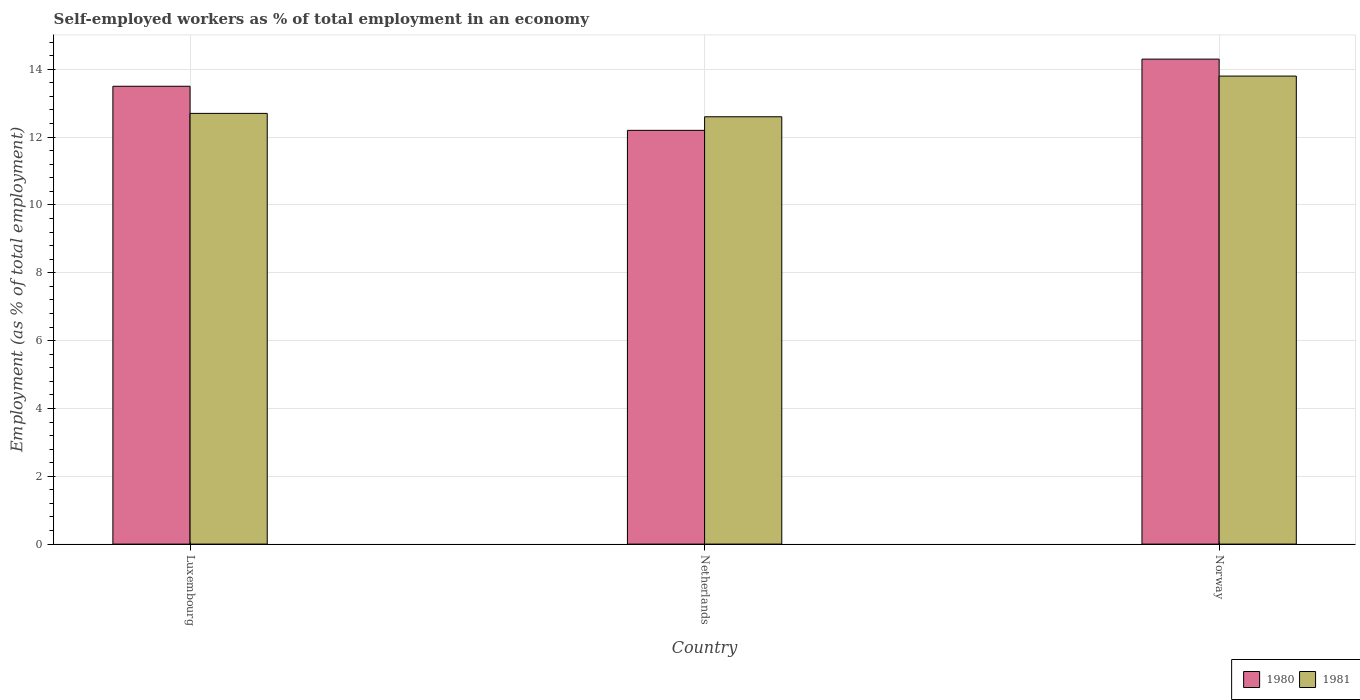How many different coloured bars are there?
Ensure brevity in your answer.  2. Are the number of bars per tick equal to the number of legend labels?
Provide a short and direct response. Yes. How many bars are there on the 1st tick from the left?
Provide a short and direct response. 2. What is the label of the 2nd group of bars from the left?
Your answer should be compact. Netherlands. In how many cases, is the number of bars for a given country not equal to the number of legend labels?
Offer a very short reply. 0. What is the percentage of self-employed workers in 1980 in Norway?
Ensure brevity in your answer.  14.3. Across all countries, what is the maximum percentage of self-employed workers in 1981?
Ensure brevity in your answer.  13.8. Across all countries, what is the minimum percentage of self-employed workers in 1981?
Your answer should be compact. 12.6. What is the total percentage of self-employed workers in 1981 in the graph?
Make the answer very short. 39.1. What is the difference between the percentage of self-employed workers in 1980 in Luxembourg and that in Norway?
Your response must be concise. -0.8. What is the difference between the percentage of self-employed workers in 1981 in Netherlands and the percentage of self-employed workers in 1980 in Norway?
Offer a very short reply. -1.7. What is the average percentage of self-employed workers in 1981 per country?
Ensure brevity in your answer.  13.03. What is the difference between the percentage of self-employed workers of/in 1981 and percentage of self-employed workers of/in 1980 in Norway?
Make the answer very short. -0.5. What is the ratio of the percentage of self-employed workers in 1980 in Netherlands to that in Norway?
Offer a very short reply. 0.85. Is the difference between the percentage of self-employed workers in 1981 in Luxembourg and Netherlands greater than the difference between the percentage of self-employed workers in 1980 in Luxembourg and Netherlands?
Your answer should be very brief. No. What is the difference between the highest and the second highest percentage of self-employed workers in 1981?
Provide a short and direct response. -1.1. What is the difference between the highest and the lowest percentage of self-employed workers in 1980?
Give a very brief answer. 2.1. How many bars are there?
Your answer should be compact. 6. What is the difference between two consecutive major ticks on the Y-axis?
Your answer should be compact. 2. Are the values on the major ticks of Y-axis written in scientific E-notation?
Provide a short and direct response. No. What is the title of the graph?
Offer a very short reply. Self-employed workers as % of total employment in an economy. Does "2002" appear as one of the legend labels in the graph?
Your response must be concise. No. What is the label or title of the Y-axis?
Provide a short and direct response. Employment (as % of total employment). What is the Employment (as % of total employment) in 1980 in Luxembourg?
Your answer should be compact. 13.5. What is the Employment (as % of total employment) of 1981 in Luxembourg?
Keep it short and to the point. 12.7. What is the Employment (as % of total employment) of 1980 in Netherlands?
Give a very brief answer. 12.2. What is the Employment (as % of total employment) of 1981 in Netherlands?
Your response must be concise. 12.6. What is the Employment (as % of total employment) in 1980 in Norway?
Provide a succinct answer. 14.3. What is the Employment (as % of total employment) in 1981 in Norway?
Your answer should be compact. 13.8. Across all countries, what is the maximum Employment (as % of total employment) in 1980?
Ensure brevity in your answer.  14.3. Across all countries, what is the maximum Employment (as % of total employment) in 1981?
Make the answer very short. 13.8. Across all countries, what is the minimum Employment (as % of total employment) of 1980?
Offer a terse response. 12.2. Across all countries, what is the minimum Employment (as % of total employment) of 1981?
Your response must be concise. 12.6. What is the total Employment (as % of total employment) in 1981 in the graph?
Keep it short and to the point. 39.1. What is the difference between the Employment (as % of total employment) in 1980 in Luxembourg and that in Norway?
Make the answer very short. -0.8. What is the difference between the Employment (as % of total employment) of 1981 in Luxembourg and that in Norway?
Give a very brief answer. -1.1. What is the average Employment (as % of total employment) of 1980 per country?
Ensure brevity in your answer.  13.33. What is the average Employment (as % of total employment) of 1981 per country?
Make the answer very short. 13.03. What is the difference between the Employment (as % of total employment) in 1980 and Employment (as % of total employment) in 1981 in Norway?
Provide a short and direct response. 0.5. What is the ratio of the Employment (as % of total employment) of 1980 in Luxembourg to that in Netherlands?
Give a very brief answer. 1.11. What is the ratio of the Employment (as % of total employment) of 1981 in Luxembourg to that in Netherlands?
Keep it short and to the point. 1.01. What is the ratio of the Employment (as % of total employment) of 1980 in Luxembourg to that in Norway?
Ensure brevity in your answer.  0.94. What is the ratio of the Employment (as % of total employment) in 1981 in Luxembourg to that in Norway?
Ensure brevity in your answer.  0.92. What is the ratio of the Employment (as % of total employment) of 1980 in Netherlands to that in Norway?
Your answer should be compact. 0.85. What is the ratio of the Employment (as % of total employment) of 1981 in Netherlands to that in Norway?
Keep it short and to the point. 0.91. What is the difference between the highest and the second highest Employment (as % of total employment) of 1980?
Your answer should be compact. 0.8. What is the difference between the highest and the lowest Employment (as % of total employment) of 1980?
Provide a short and direct response. 2.1. What is the difference between the highest and the lowest Employment (as % of total employment) of 1981?
Your response must be concise. 1.2. 